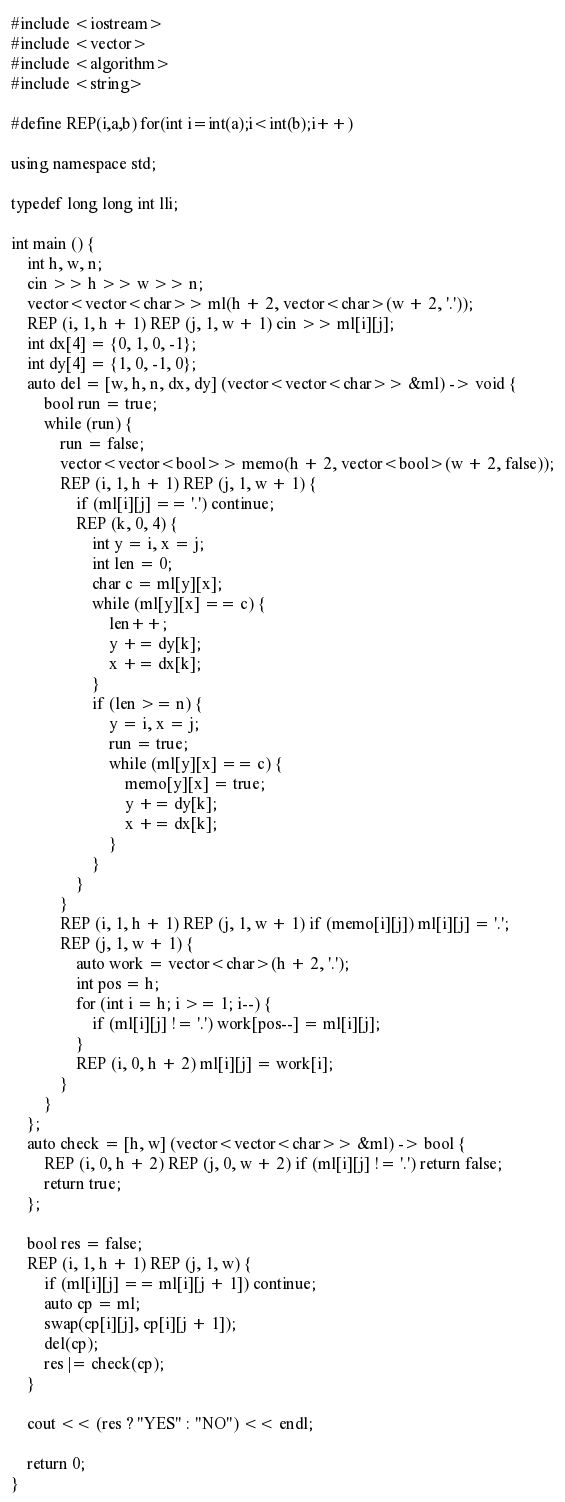Convert code to text. <code><loc_0><loc_0><loc_500><loc_500><_C++_>#include <iostream>
#include <vector>
#include <algorithm>
#include <string>

#define REP(i,a,b) for(int i=int(a);i<int(b);i++)

using namespace std;

typedef long long int lli;

int main () {
    int h, w, n;
    cin >> h >> w >> n;
    vector<vector<char>> ml(h + 2, vector<char>(w + 2, '.'));
    REP (i, 1, h + 1) REP (j, 1, w + 1) cin >> ml[i][j];
    int dx[4] = {0, 1, 0, -1};
    int dy[4] = {1, 0, -1, 0};
    auto del = [w, h, n, dx, dy] (vector<vector<char>> &ml) -> void {
        bool run = true;
        while (run) {
            run = false;
            vector<vector<bool>> memo(h + 2, vector<bool>(w + 2, false));
            REP (i, 1, h + 1) REP (j, 1, w + 1) {
                if (ml[i][j] == '.') continue;
                REP (k, 0, 4) {
                    int y = i, x = j;
                    int len = 0;
                    char c = ml[y][x];
                    while (ml[y][x] == c) {
                        len++;
                        y += dy[k];
                        x += dx[k];
                    }
                    if (len >= n) {
                        y = i, x = j;
                        run = true;
                        while (ml[y][x] == c) {
                            memo[y][x] = true;
                            y += dy[k];
                            x += dx[k];
                        }
                    }
                }
            }
            REP (i, 1, h + 1) REP (j, 1, w + 1) if (memo[i][j]) ml[i][j] = '.';
            REP (j, 1, w + 1) {
                auto work = vector<char>(h + 2, '.');
                int pos = h;
                for (int i = h; i >= 1; i--) {
                    if (ml[i][j] != '.') work[pos--] = ml[i][j];
                }
                REP (i, 0, h + 2) ml[i][j] = work[i];
            }
        }
    };
    auto check = [h, w] (vector<vector<char>> &ml) -> bool {
        REP (i, 0, h + 2) REP (j, 0, w + 2) if (ml[i][j] != '.') return false;
        return true;
    };

    bool res = false;
    REP (i, 1, h + 1) REP (j, 1, w) {
        if (ml[i][j] == ml[i][j + 1]) continue;
        auto cp = ml;
        swap(cp[i][j], cp[i][j + 1]);
        del(cp);
        res |= check(cp);
    }

    cout << (res ? "YES" : "NO") << endl;

    return 0;
}</code> 